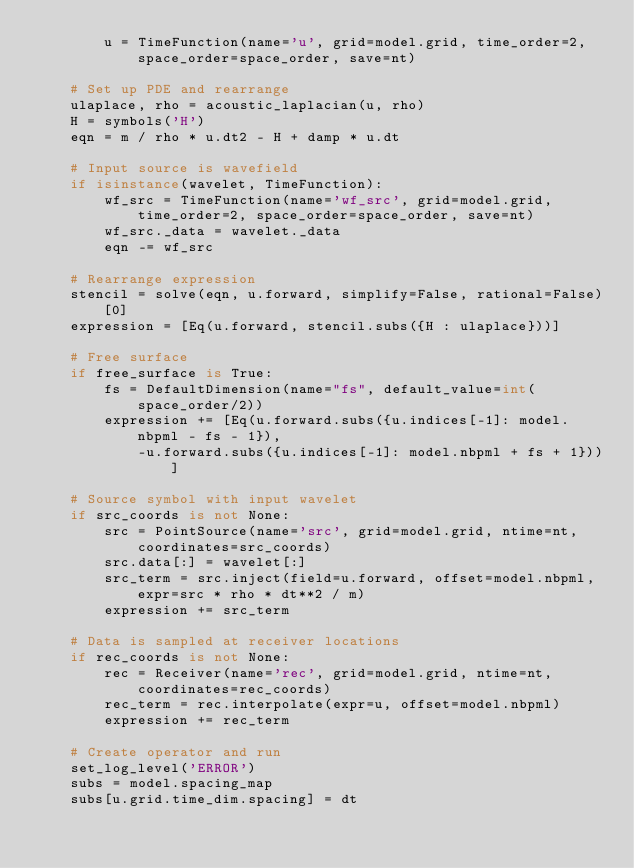Convert code to text. <code><loc_0><loc_0><loc_500><loc_500><_Python_>        u = TimeFunction(name='u', grid=model.grid, time_order=2, space_order=space_order, save=nt)

    # Set up PDE and rearrange
    ulaplace, rho = acoustic_laplacian(u, rho)
    H = symbols('H')
    eqn = m / rho * u.dt2 - H + damp * u.dt
    
    # Input source is wavefield
    if isinstance(wavelet, TimeFunction):
        wf_src = TimeFunction(name='wf_src', grid=model.grid, time_order=2, space_order=space_order, save=nt)
        wf_src._data = wavelet._data
        eqn -= wf_src
    
    # Rearrange expression
    stencil = solve(eqn, u.forward, simplify=False, rational=False)[0]
    expression = [Eq(u.forward, stencil.subs({H : ulaplace}))]

    # Free surface
    if free_surface is True:
        fs = DefaultDimension(name="fs", default_value=int(space_order/2))
        expression += [Eq(u.forward.subs({u.indices[-1]: model.nbpml - fs - 1}), 
            -u.forward.subs({u.indices[-1]: model.nbpml + fs + 1}))]

    # Source symbol with input wavelet
    if src_coords is not None:
        src = PointSource(name='src', grid=model.grid, ntime=nt, coordinates=src_coords)
        src.data[:] = wavelet[:]
        src_term = src.inject(field=u.forward, offset=model.nbpml, expr=src * rho * dt**2 / m)
        expression += src_term

    # Data is sampled at receiver locations
    if rec_coords is not None:
        rec = Receiver(name='rec', grid=model.grid, ntime=nt, coordinates=rec_coords)
        rec_term = rec.interpolate(expr=u, offset=model.nbpml)
        expression += rec_term

    # Create operator and run
    set_log_level('ERROR')
    subs = model.spacing_map
    subs[u.grid.time_dim.spacing] = dt</code> 